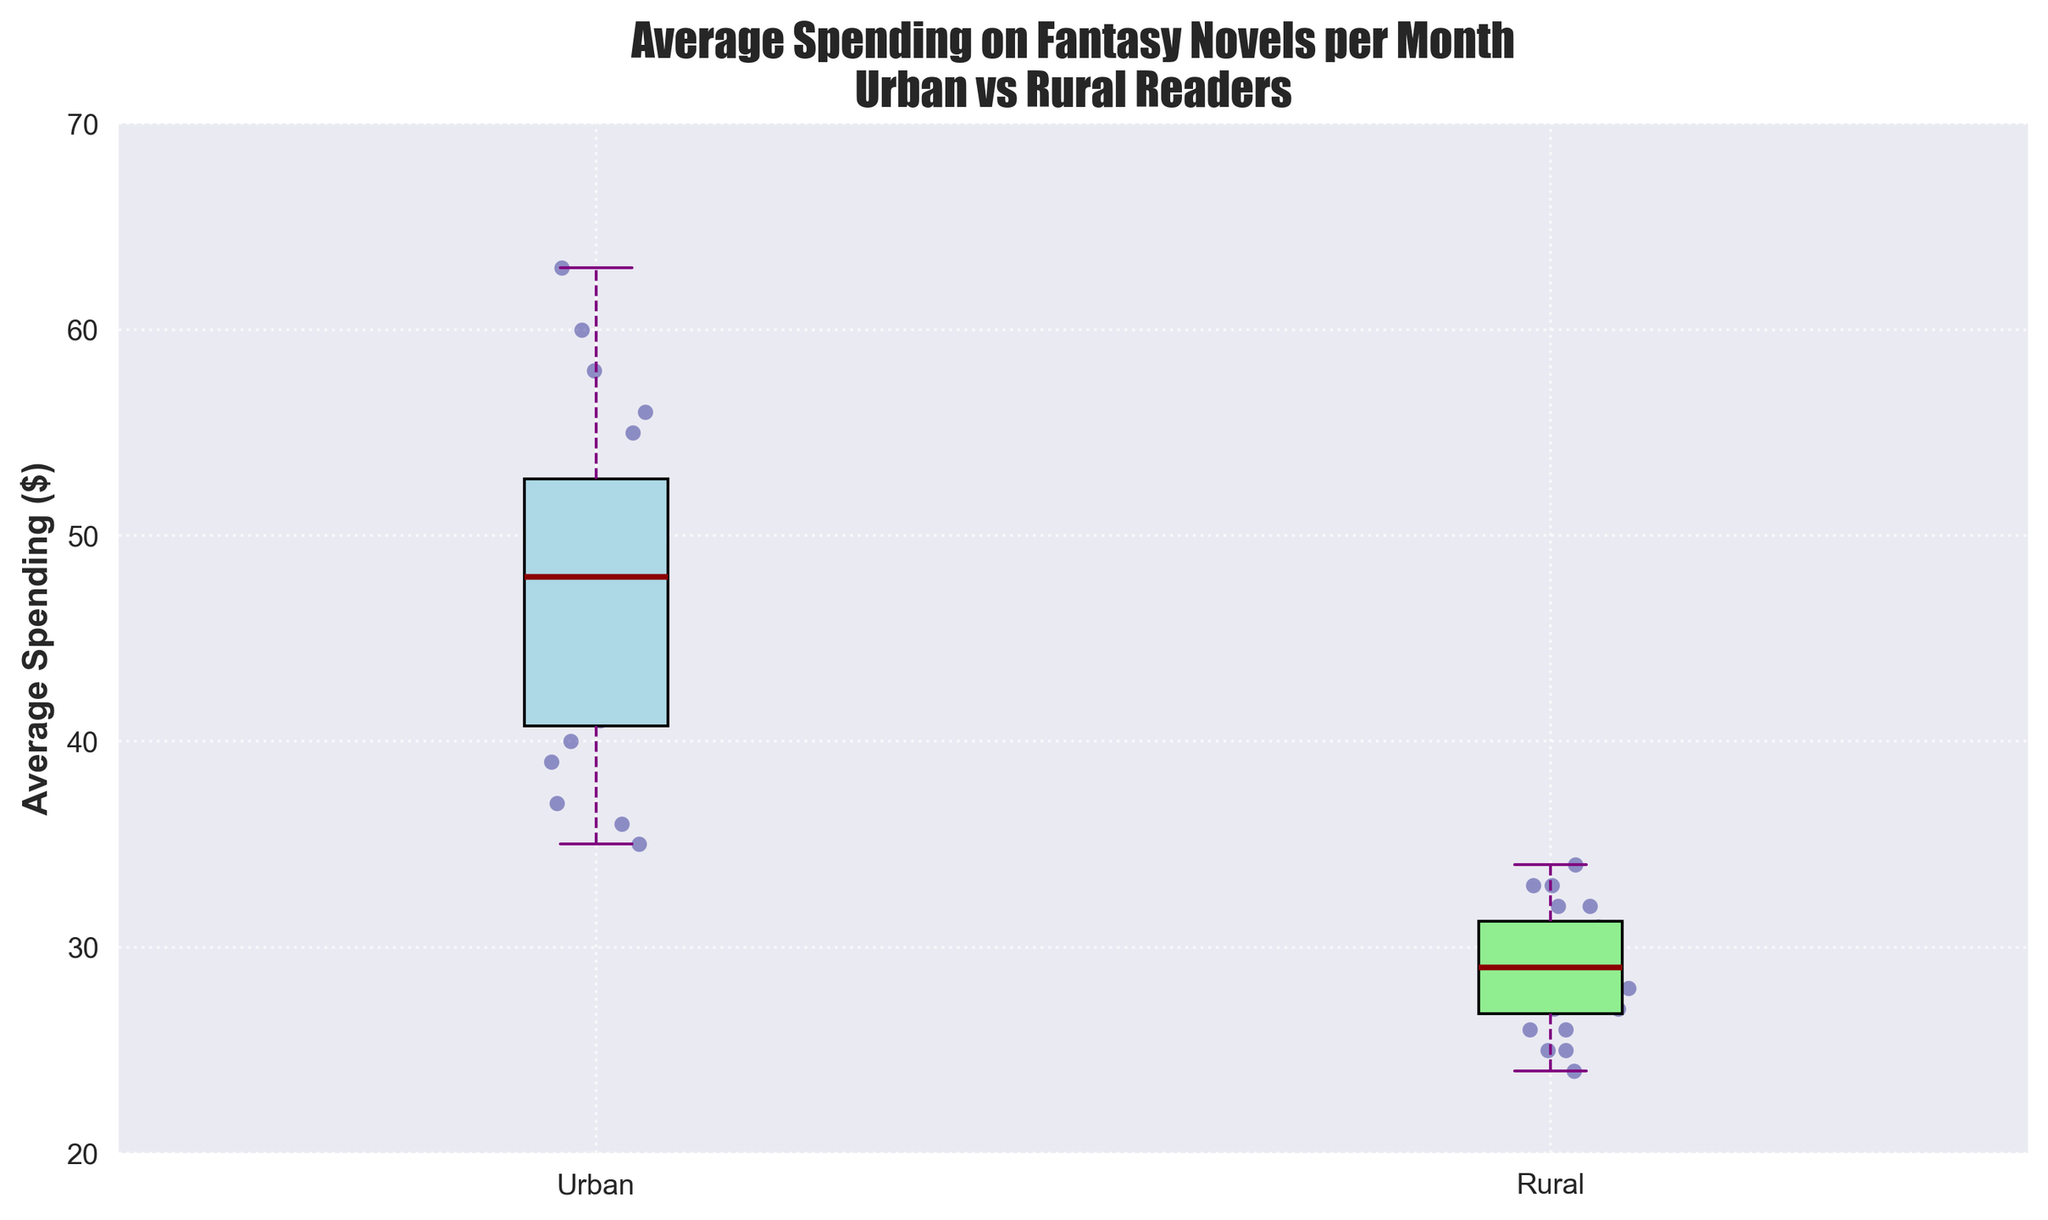What are the labels used for the two groups in the plot? The box plot compares 'Urban' and 'Rural' readers, with these labels clearly indicated on the x-axis.
Answer: Urban and Rural What is the title of the plot? The title is displayed at the top of the plot, indicating what the plot represents.
Answer: Average Spending on Fantasy Novels per Month – Urban vs Rural Readers What do the colors of the box plots represent? The plot uses different colors for the box plots of each group: light blue for Urban readers and light green for Rural readers. This color distinction helps differentiate between the two groups visually.
Answer: Light blue for Urban, light green for Rural What is the median spending for Urban readers? The median value is indicated by the dark red line inside the box of the Urban readers.
Answer: Around $50 Which group shows a higher median spending on fantasy novels? By comparing the dark red lines in both box plots, it is clear that the Urban readers have a higher median value than the Rural readers.
Answer: Urban What is the range of average spending for Rural readers? The range is the difference between the maximum and minimum values indicated by the whiskers.
Answer: $24 to $34 How do the interquartile ranges (IQR) compare between Urban and Rural readers? The IQR, represented by the height of the boxes, can be compared to see which group's spending is more spread out in the middle 50%. The Urban readers' IQR is larger than the Rural readers' IQR.
Answer: Urban IQR is larger How many points are scattered for Rural readers? By counting the individual scatter points around the Rural box plot, one can determine the exact number of data points.
Answer: 20 Are there any outliers in either of the groups? Outliers would be marked as individual points outside the whisker range. There are no outliers visible in either group.
Answer: No outliers What is the maximum average spending for Urban readers? The highest value marked by the top whisker in the Urban box plot indicates the maximum average spending amount.
Answer: $63 